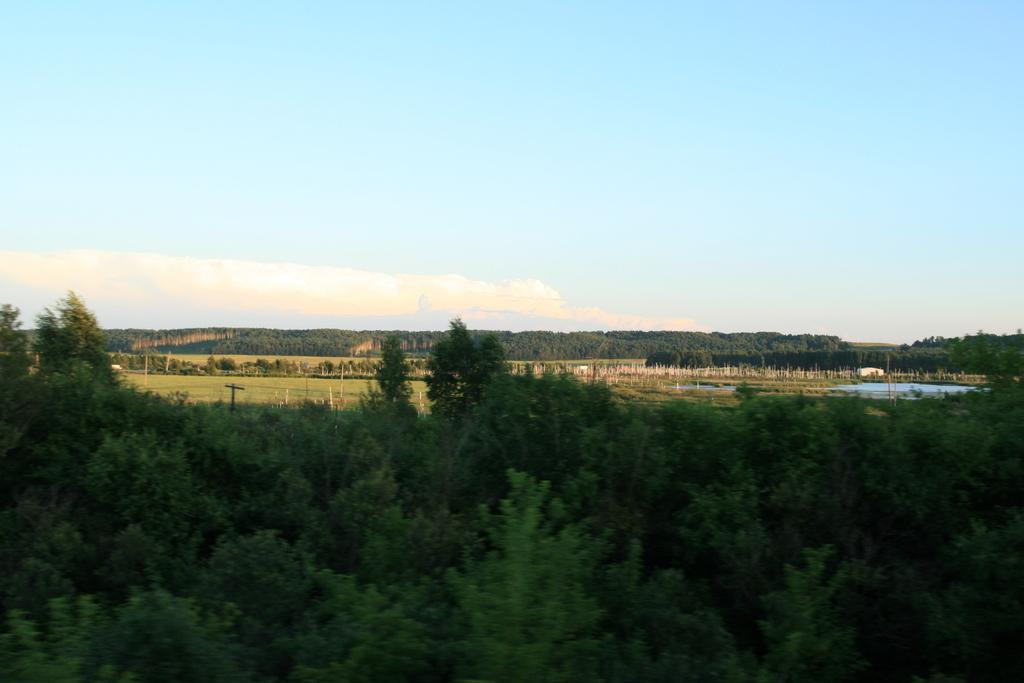What type of vegetation can be seen in the image? There are trees in the image. What is the color of the trees in the image? The trees are green in color. What else can be seen in the image besides the trees? There are poles in the image. What is visible in the sky in the image? The sky is blue and white in color. Can you see a heart-shaped cream cake in the image? There is no heart-shaped cream cake present in the image. 